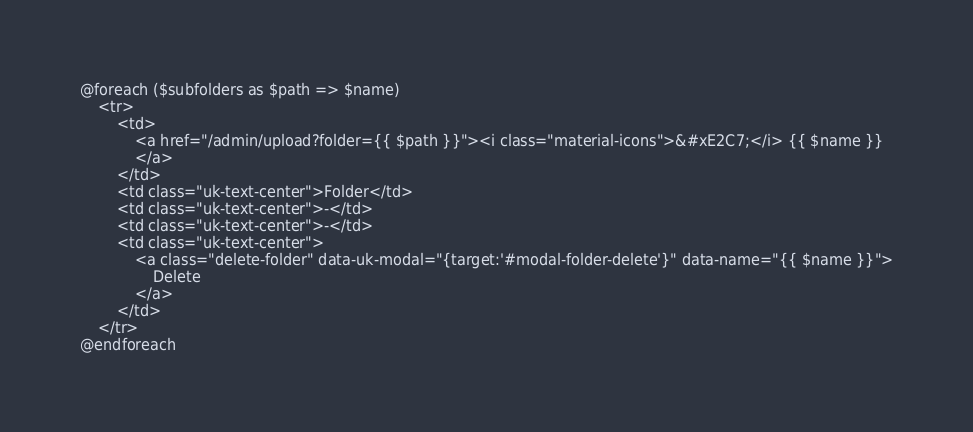<code> <loc_0><loc_0><loc_500><loc_500><_PHP_>@foreach ($subfolders as $path => $name)
    <tr>
        <td>
            <a href="/admin/upload?folder={{ $path }}"><i class="material-icons">&#xE2C7;</i> {{ $name }}
            </a>
        </td>
        <td class="uk-text-center">Folder</td>
        <td class="uk-text-center">-</td>
        <td class="uk-text-center">-</td>
        <td class="uk-text-center">
            <a class="delete-folder" data-uk-modal="{target:'#modal-folder-delete'}" data-name="{{ $name }}">
                Delete
            </a>
        </td>
    </tr>
@endforeach</code> 